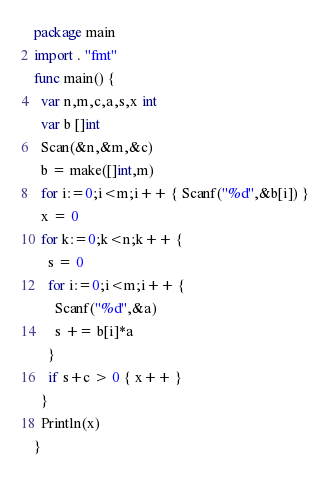Convert code to text. <code><loc_0><loc_0><loc_500><loc_500><_Go_>package main
import . "fmt"
func main() {
  var n,m,c,a,s,x int
  var b []int
  Scan(&n,&m,&c)
  b = make([]int,m)
  for i:=0;i<m;i++ { Scanf("%d",&b[i]) }
  x = 0
  for k:=0;k<n;k++ {
    s = 0
    for i:=0;i<m;i++ {
      Scanf("%d",&a)
      s += b[i]*a
    }
    if s+c > 0 { x++ }
  }
  Println(x)
}</code> 